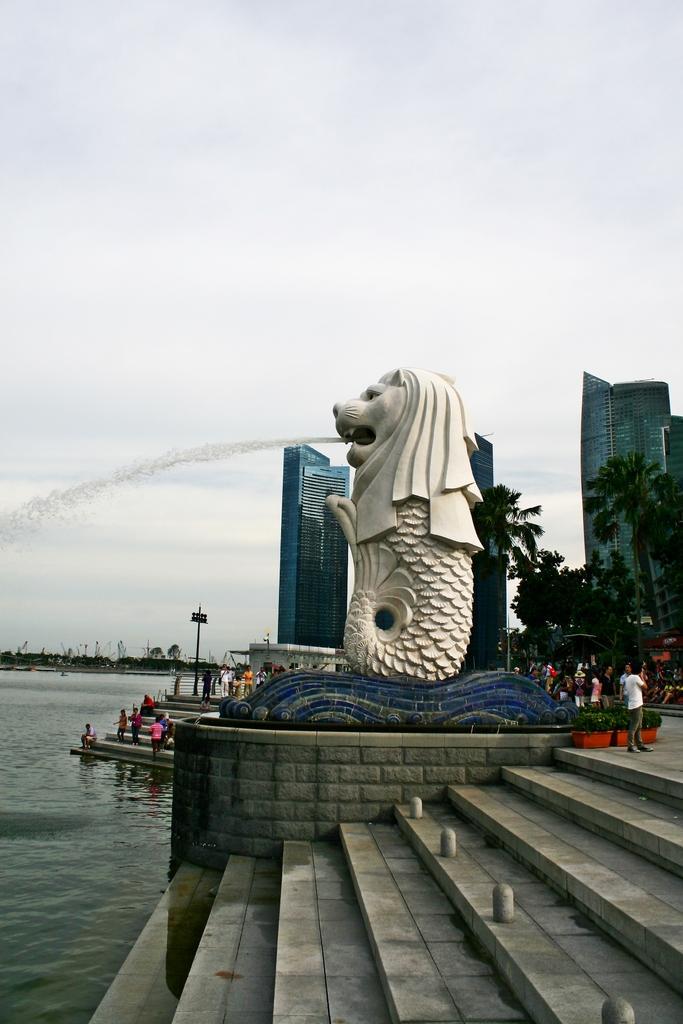Could you give a brief overview of what you see in this image? In the middle of the picture, we see a fountain in the shape of half-lion and half-fish. At the bottom of that, we see a staircase. On the left side, we see a water body and children are standing on the staircase. On the right side, we see people standing on the road. There are trees, buildings and poles in the background. 